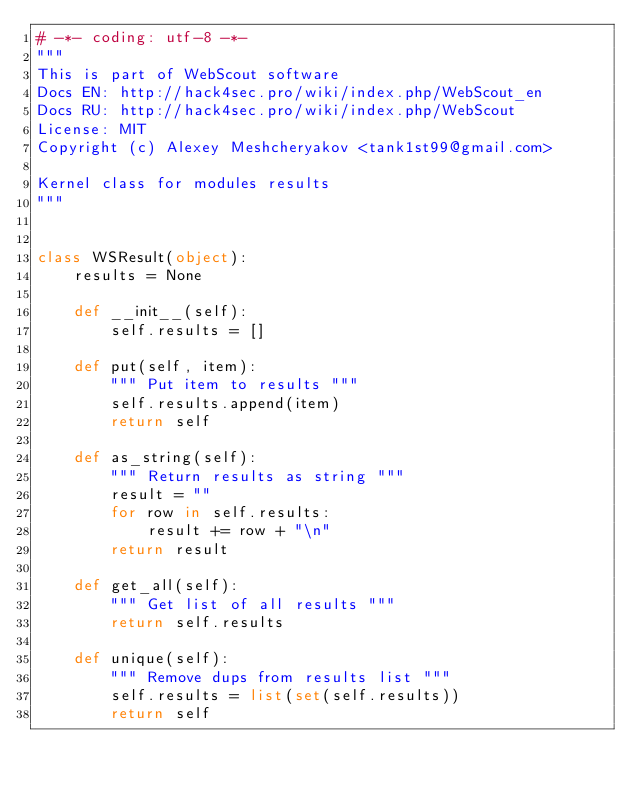<code> <loc_0><loc_0><loc_500><loc_500><_Python_># -*- coding: utf-8 -*-
"""
This is part of WebScout software
Docs EN: http://hack4sec.pro/wiki/index.php/WebScout_en
Docs RU: http://hack4sec.pro/wiki/index.php/WebScout
License: MIT
Copyright (c) Alexey Meshcheryakov <tank1st99@gmail.com>

Kernel class for modules results
"""


class WSResult(object):
    results = None

    def __init__(self):
        self.results = []

    def put(self, item):
        """ Put item to results """
        self.results.append(item)
        return self

    def as_string(self):
        """ Return results as string """
        result = ""
        for row in self.results:
            result += row + "\n"
        return result

    def get_all(self):
        """ Get list of all results """
        return self.results

    def unique(self):
        """ Remove dups from results list """
        self.results = list(set(self.results))
        return self
</code> 